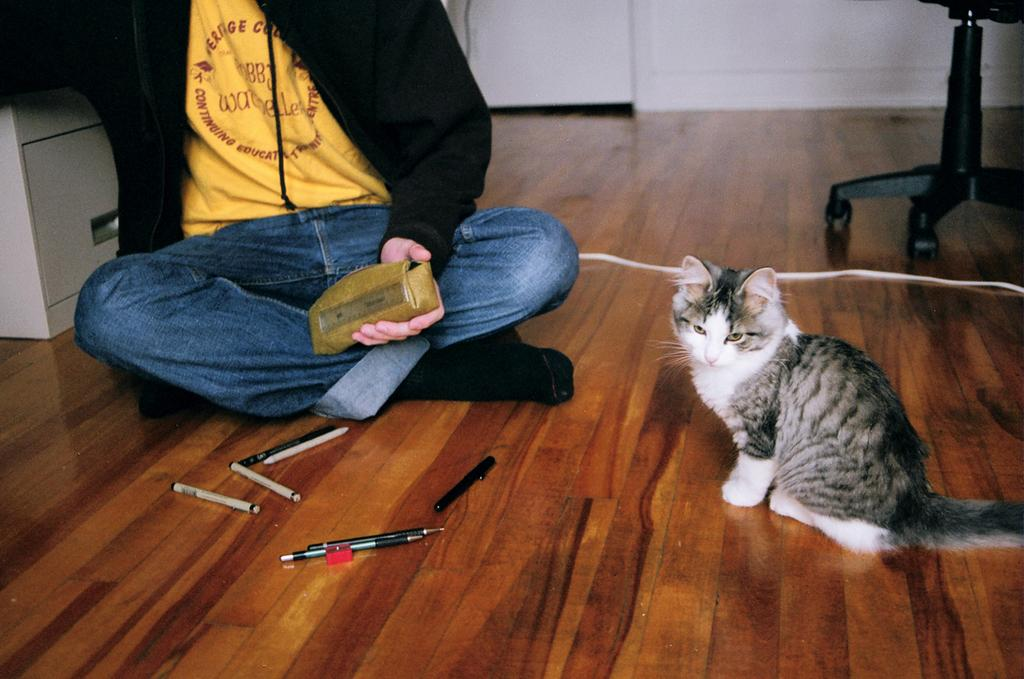What is the main subject in the image? There is a person in the image. What animal is present in the image? There is a cat seated on the floor. What items are in front of the person? There are pens and a sharpener in front of the person. What object is beside the cat? There is a cable beside the cat. What type of furniture is in the image? There is a chair in the image. How does the ocean contribute to the pollution in the image? There is no ocean present in the image, so it cannot contribute to any pollution. How many cows are visible in the image? There are no cows present in the image. 